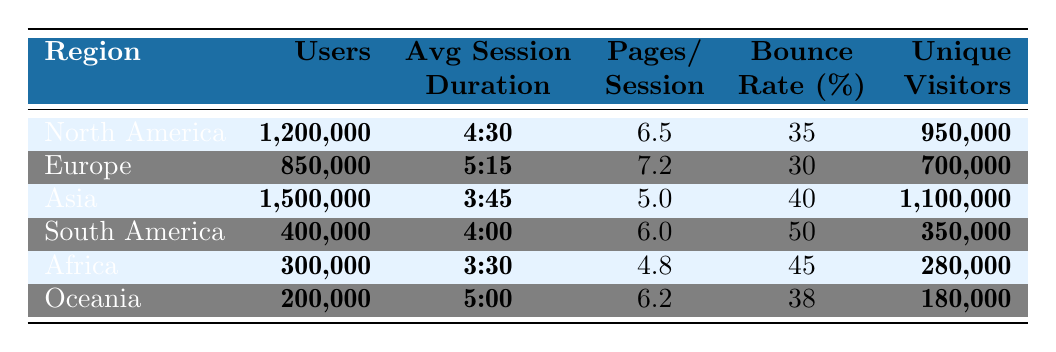What is the average session duration in Europe? From the table, the average session duration for Europe is listed as 5:15, which can be represented as 5 minutes and 15 seconds.
Answer: 5:15 Which region has the highest number of unique visitors? By examining the Unique Visitors column, Asia has the highest number with 1,100,000 unique visitors, while other regions have fewer.
Answer: Asia What is the total number of users across all regions? To find the total users, we sum the Users values from each region: 1,200,000 + 850,000 + 1,500,000 + 400,000 + 300,000 + 200,000 = 4,450,000.
Answer: 4,450,000 Is the bounce rate in South America higher than in Africa? In the table, the bounce rate for South America is 50%, while for Africa it is 45%. Since 50% is higher than 45%, the statement is true.
Answer: Yes What is the average pages per session of North America and Oceania combined? The pages per session for North America is 6.5 and for Oceania is 6.2. Summing these gives 6.5 + 6.2 = 12.7, then divide by 2 for the average = 12.7 / 2 = 6.35.
Answer: 6.35 Which region has the lowest number of users? The Users column indicates that Oceania has the lowest user count with 200,000 users compared to other regions.
Answer: Oceania What is the bounce rate difference between Asia and Europe? Asia's bounce rate is 40% and Europe's is 30%. The difference is 40% - 30% = 10%.
Answer: 10% Does North America have a higher average session duration than Asia? North America's average session duration is 4:30 while Asia's is 3:45. Since 4:30 is greater than 3:45, the answer is yes.
Answer: Yes What is the total number of unique visitors from Europe and South America? Adding the unique visitors from Europe (700,000) and South America (350,000) gives 700,000 + 350,000 = 1,050,000.
Answer: 1,050,000 What is the average bounce rate across all regions? The bounce rates for each region are: North America (35%), Europe (30%), Asia (40%), South America (50%), Africa (45%), and Oceania (38%). Calculating the average: (35 + 30 + 40 + 50 + 45 + 38) / 6 = 38.
Answer: 38 